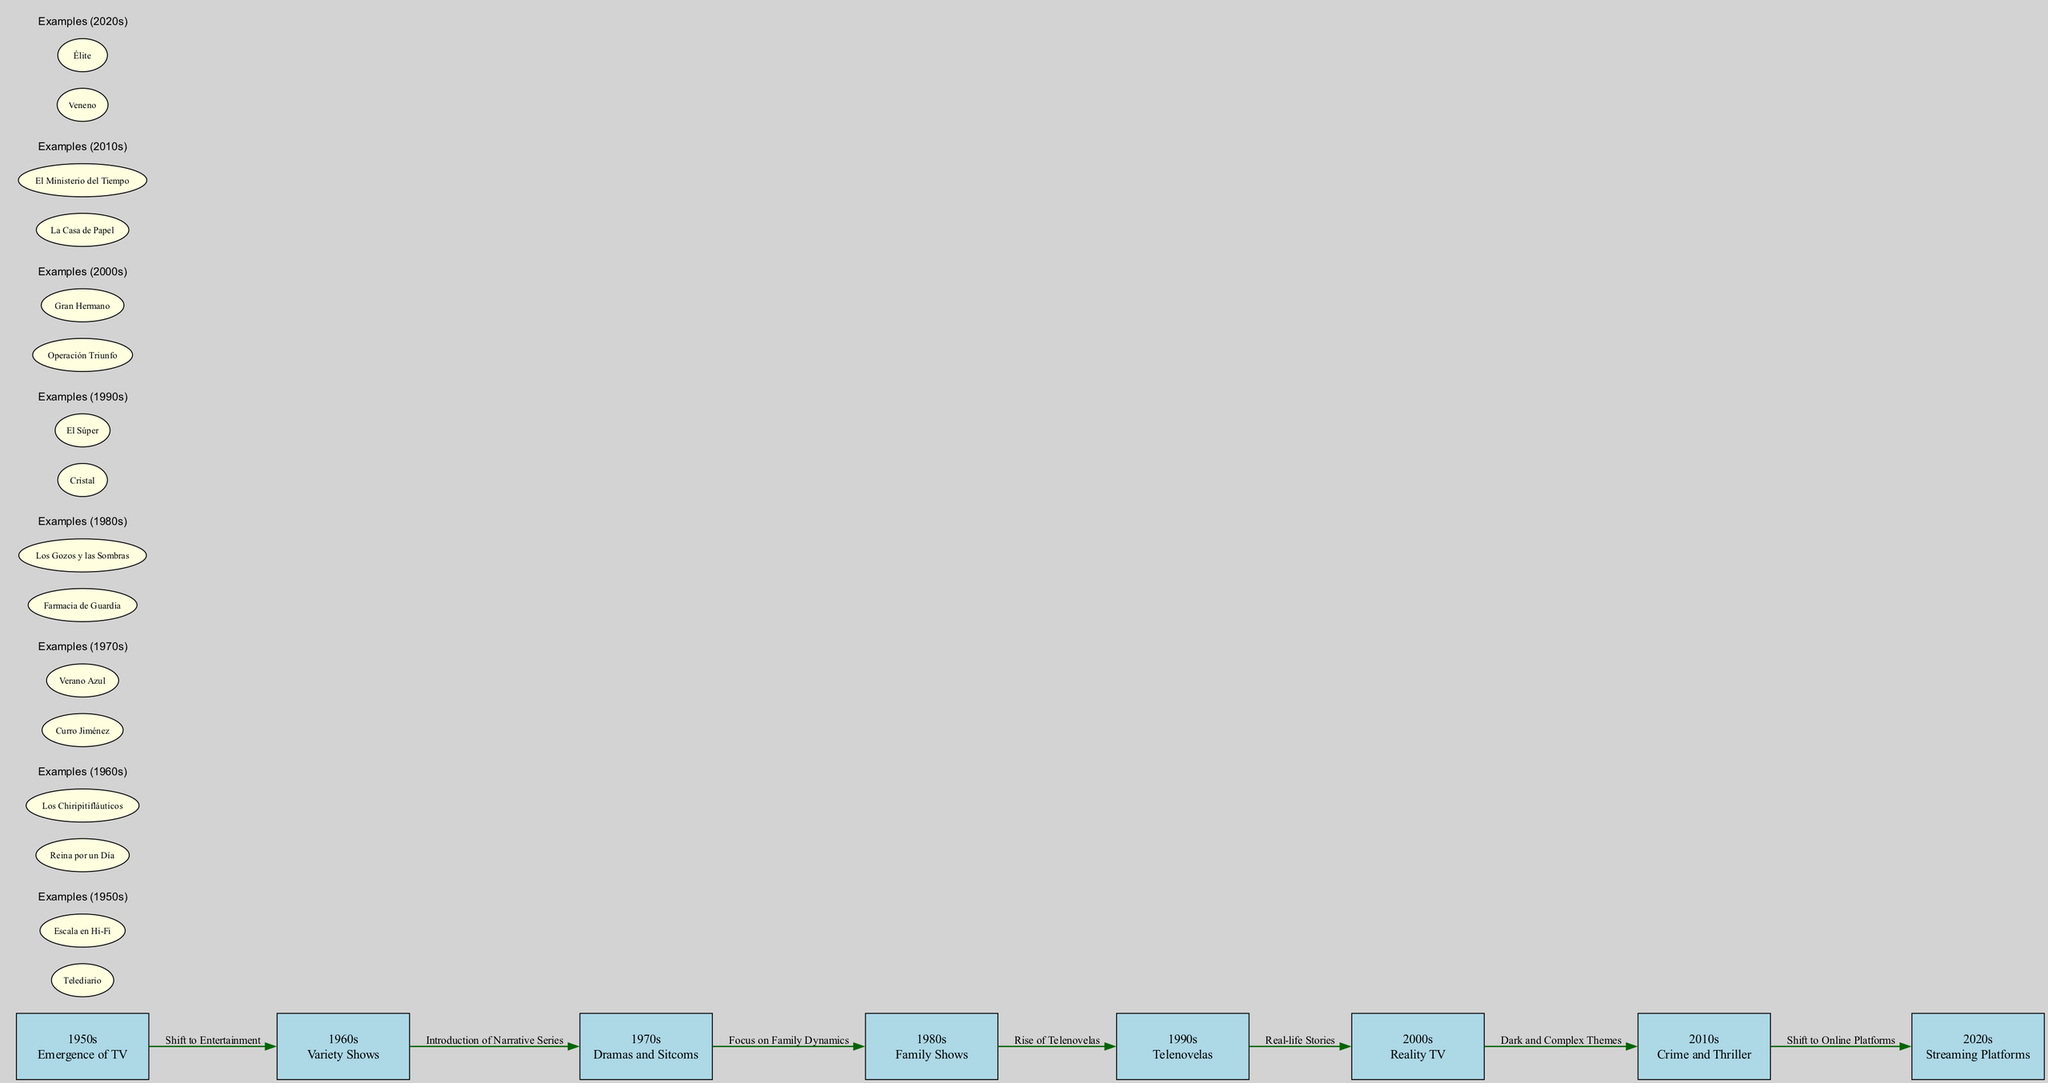What genre first emerged on Spanish television in the 1950s? According to the diagram, the 1950s is labeled as the "Emergence of TV," indicating that this was the period when the television medium was first introduced in Spain. The description does not specify a genre but highlights the start of television itself. Therefore, the answer focuses on the significance of the era rather than a specific genre.
Answer: Emergence of TV Which decade is associated with the rise of Telenovelas? The diagram links the 1990s node with the label "Rise of Telenovelas." This means that during the 1990s, Telenovelas became a prominent genre on Spanish television, illustrating a shift in entertainment content.
Answer: 1990s How many edges connect the decade nodes in the diagram? By counting the edges presented between the decade nodes, we see there are 7 connections. Each edge depicts a transition from one genre trend to another over the decades.
Answer: 7 What type of shows gained popularity in the 2010s according to the diagram? The diagram indicates that the 2010s are characterized by "Crime and Thriller" shows. This genre is highlighted specifically as a representative trend for that decade, showing its prevalence in that era.
Answer: Crime and Thriller What was the main thematic shift in Spanish TV shows from the 2000s to the 2010s? The transition from the 2000s to the 2010s is marked by the label "Dark and Complex Themes." This indicates a significant thematic evolution where television content became more intricate and explored deeper narratives, moving away from lighter entertainment formats prevalent in earlier decades.
Answer: Dark and Complex Themes Which decade introduced streaming platforms as a significant genre medium? In the diagram, the 2020s node directly indicates "Streaming Platforms" as its description. This suggests that this decade is characterized by the rise of streaming services influencing the formats and genres of Spanish television shows.
Answer: 2020s What was the focus of Spanish TV shows during the 1980s? The edge connecting the 1980s to the 1990s is labeled "Focus on Family Dynamics," highlighting that during this decade, television productions primarily centered around family themes and dynamics, shaping the content of that era.
Answer: Family Dynamics Which example show from the 1970s depicted a narrative series? The diagram lists examples such as "Curro Jiménez" and "Verano Azul" under the 1970s node, indicating that these shows were significant narrative series of that time. Both contributed to the broadening of storytelling on Spanish television.
Answer: Curro Jiménez What type of shows became prominent after the shift from the 1960s to the 1970s? The diagram states "Introduction of Narrative Series" as the edge label when transitioning from the 1960s to the 1970s. This signifies that narrative series began to dominate the television landscape following this period.
Answer: Narrative Series 